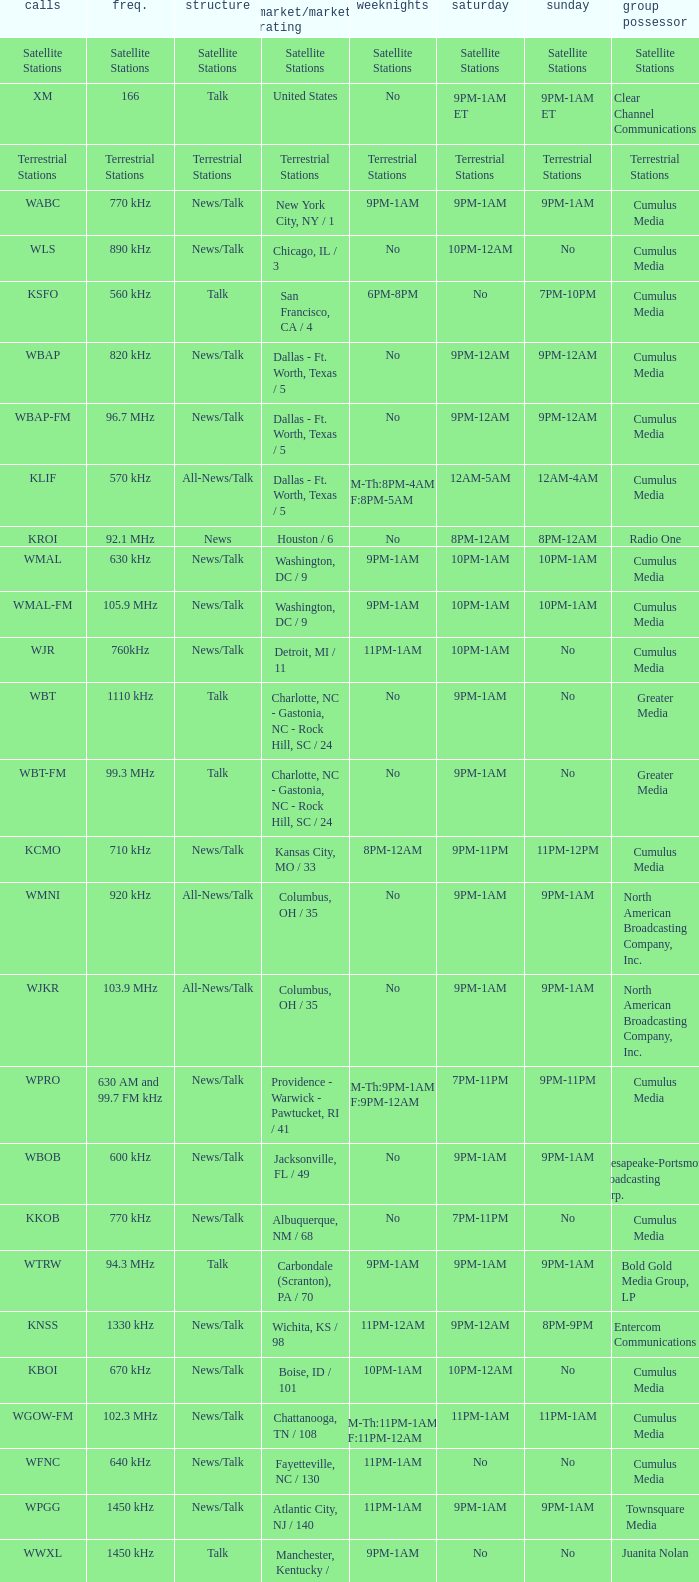What is the market for the 11pm-1am Saturday game? Chattanooga, TN / 108. 